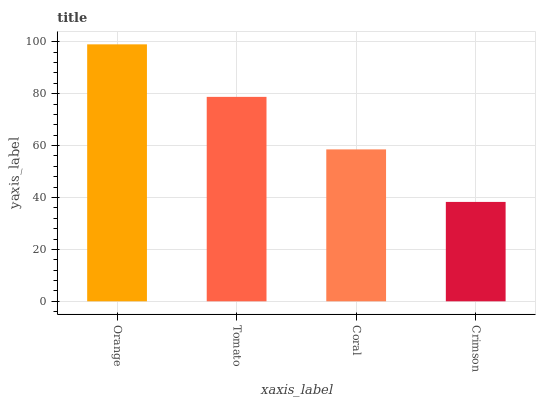Is Crimson the minimum?
Answer yes or no. Yes. Is Orange the maximum?
Answer yes or no. Yes. Is Tomato the minimum?
Answer yes or no. No. Is Tomato the maximum?
Answer yes or no. No. Is Orange greater than Tomato?
Answer yes or no. Yes. Is Tomato less than Orange?
Answer yes or no. Yes. Is Tomato greater than Orange?
Answer yes or no. No. Is Orange less than Tomato?
Answer yes or no. No. Is Tomato the high median?
Answer yes or no. Yes. Is Coral the low median?
Answer yes or no. Yes. Is Crimson the high median?
Answer yes or no. No. Is Crimson the low median?
Answer yes or no. No. 